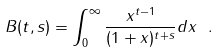Convert formula to latex. <formula><loc_0><loc_0><loc_500><loc_500>\ B ( t , s ) = \int _ { 0 } ^ { \infty } \frac { x ^ { t - 1 } } { ( 1 + x ) ^ { t + s } } d x \ .</formula> 